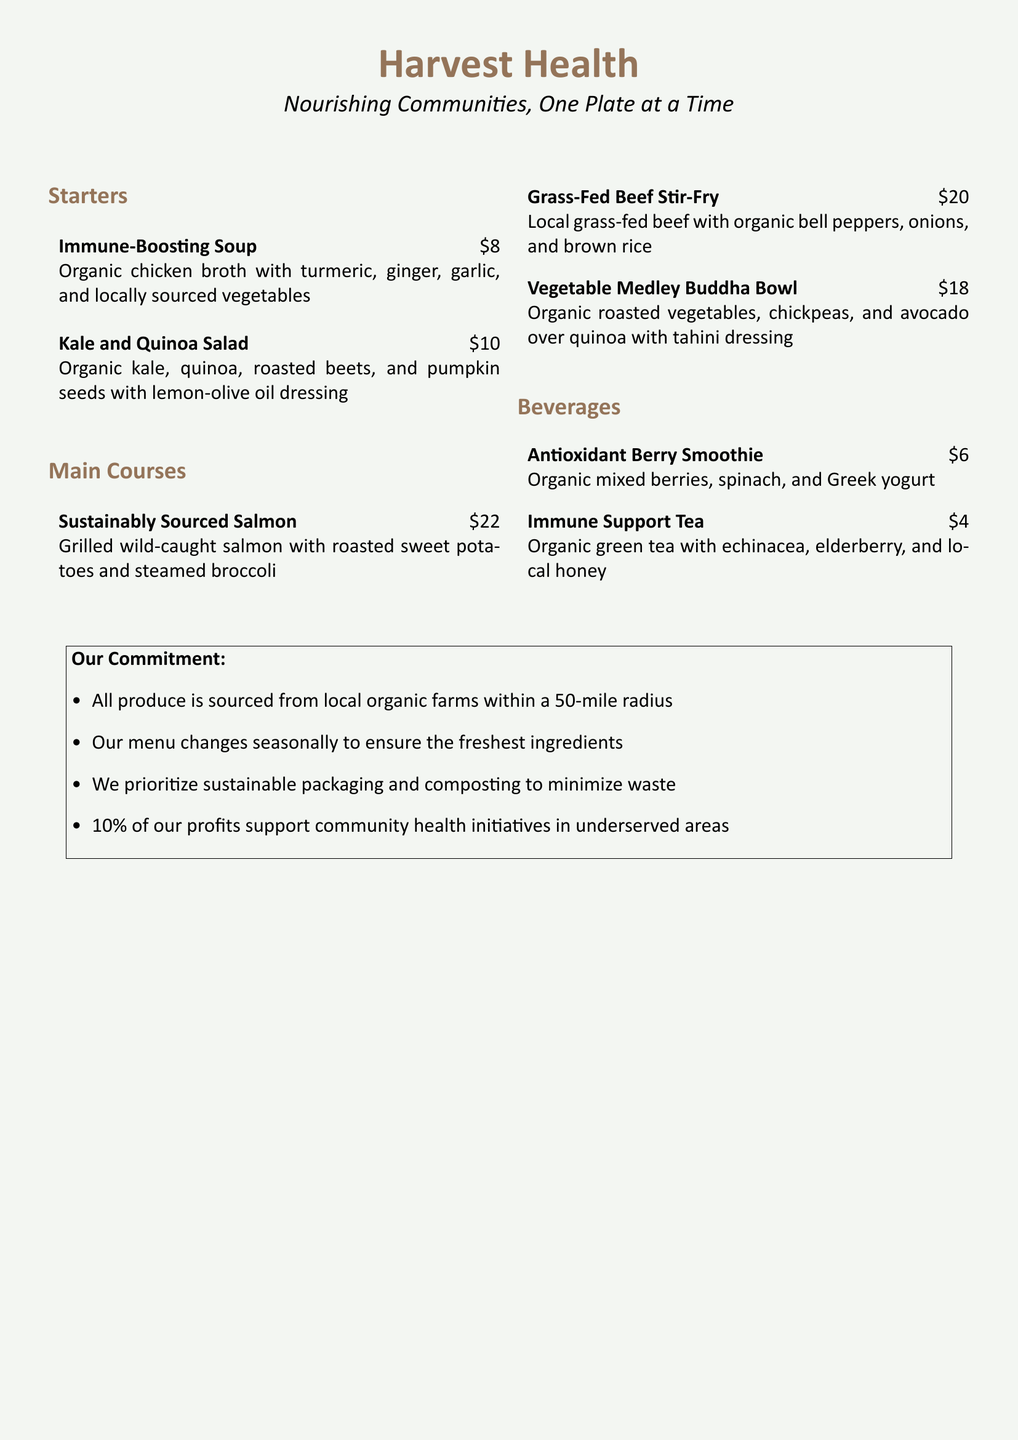What is the name of the restaurant? The name of the restaurant is found at the top of the menu document.
Answer: Harvest Health What is the price of the Kale and Quinoa Salad? The price can be found next to the dish name in the starters section.
Answer: $10 Which main course features sustainably sourced salmon? This information can be identified in the main courses section of the menu.
Answer: Sustainably Sourced Salmon What is the main ingredient in the Immune Support Tea? The main ingredient is specified in the beverages section of the menu.
Answer: Organic green tea How many items are listed under the Beverages section? This can be determined by counting the bullet points in the stated section.
Answer: 2 What percentage of profits support community health initiatives? This information is indicated in the commitment section of the menu.
Answer: 10% What dressing is used in the Vegetable Medley Buddha Bowl? The dressing is mentioned in the description of the dish in the main courses section.
Answer: Tahini dressing What type of packaging does the restaurant prioritize? This commitment is outlined in the restaurant’s commitment section.
Answer: Sustainable packaging How are the ingredients sourced for the menu? This is described in the commitment section at the bottom of the document.
Answer: From local organic farms within a 50-mile radius 